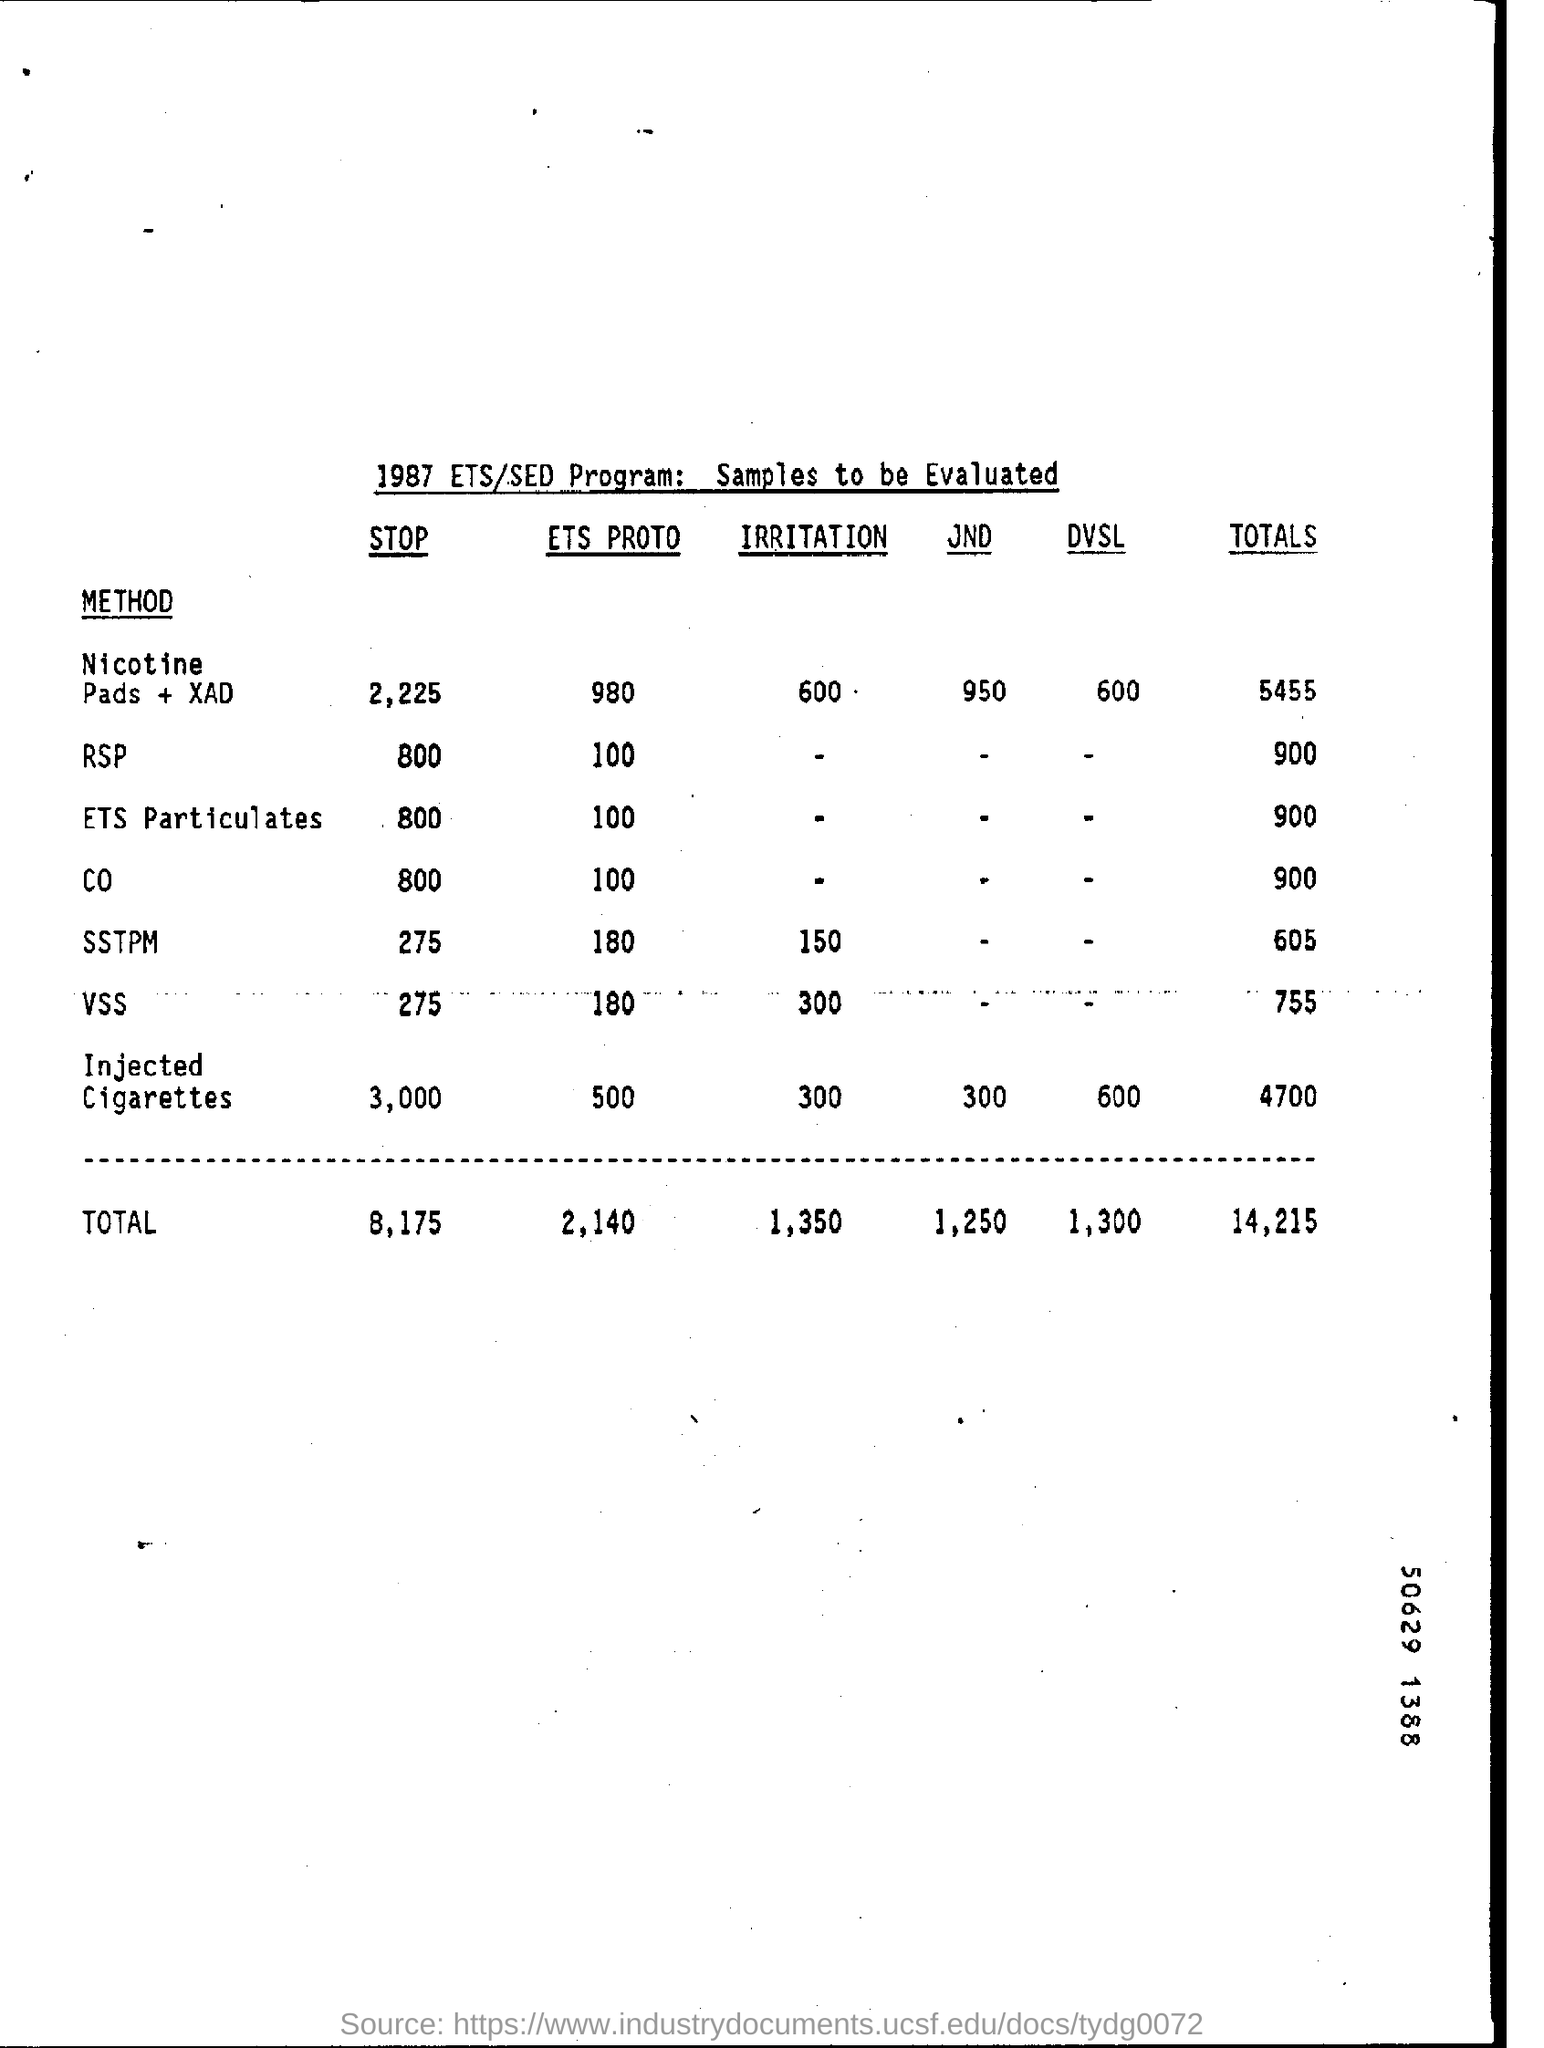Indicate a few pertinent items in this graphic. The ETS Proto of ETS Particulates is 100, indicating that the ETS particles are 100% effective in reducing pollution. 